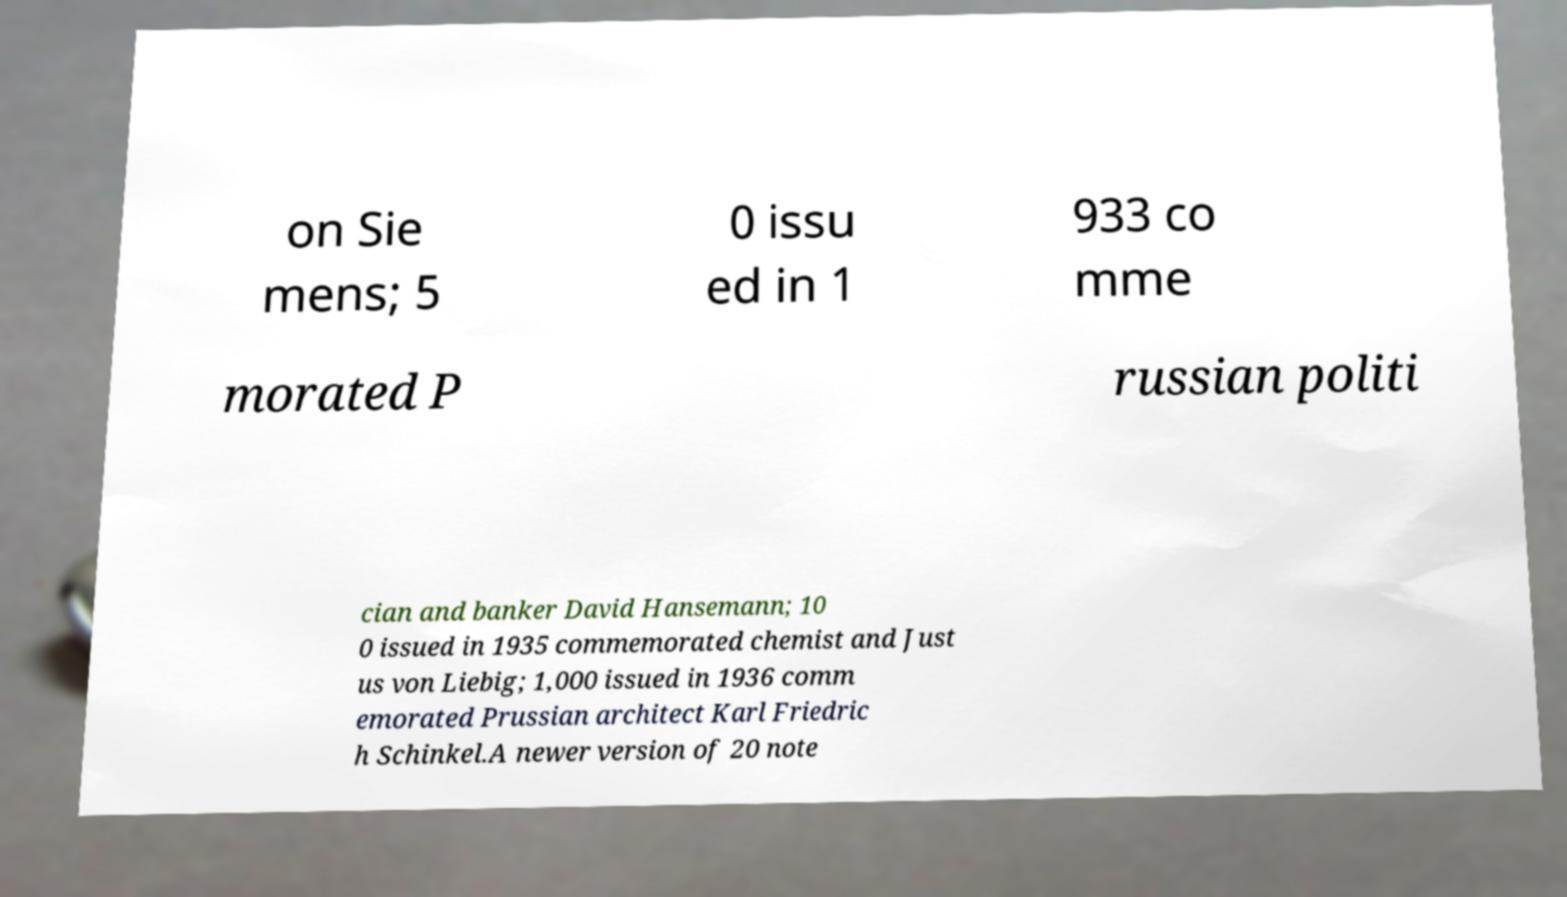Please read and relay the text visible in this image. What does it say? on Sie mens; 5 0 issu ed in 1 933 co mme morated P russian politi cian and banker David Hansemann; 10 0 issued in 1935 commemorated chemist and Just us von Liebig; 1,000 issued in 1936 comm emorated Prussian architect Karl Friedric h Schinkel.A newer version of 20 note 